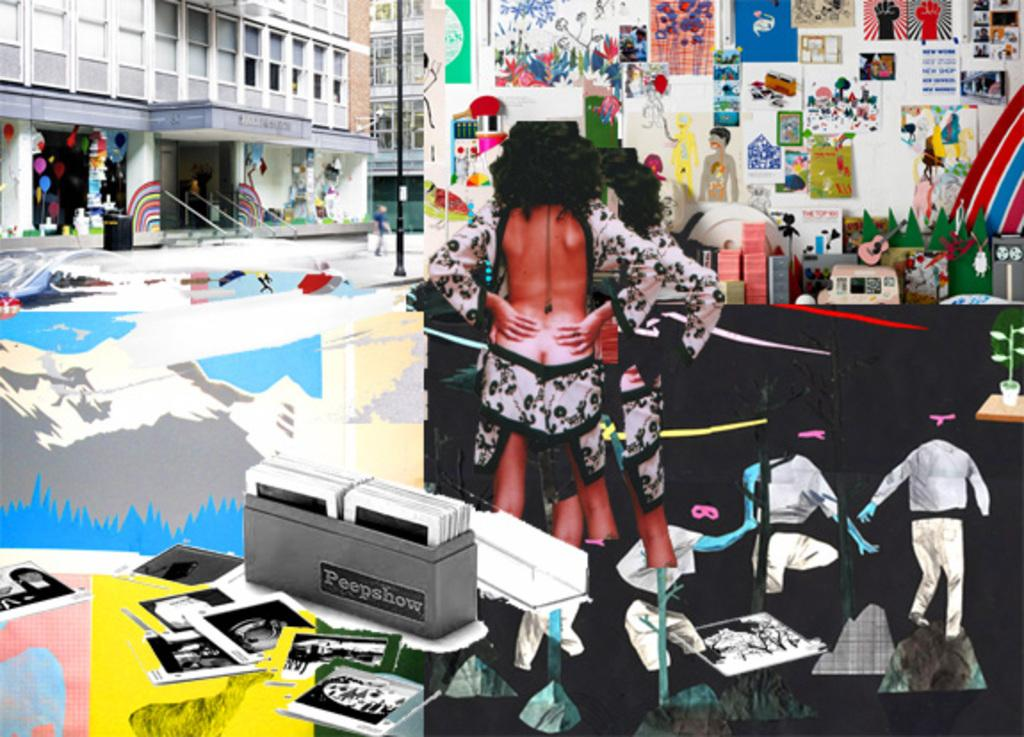What can be seen in the image involving human presence? There are people standing in the image. What type of structures are visible in the image? There are buildings in the image. What is attached to the wall in the image? There are pipes attached to the wall in the image. Can you describe any other objects present in the image? There are other objects present in the image, but their specific details are not mentioned in the provided facts. How does the image show people expressing pain? The image does not show people expressing pain; it only shows people standing. What type of respect is shown in the image? The image does not show any specific type of respect; it only shows people standing and buildings. 